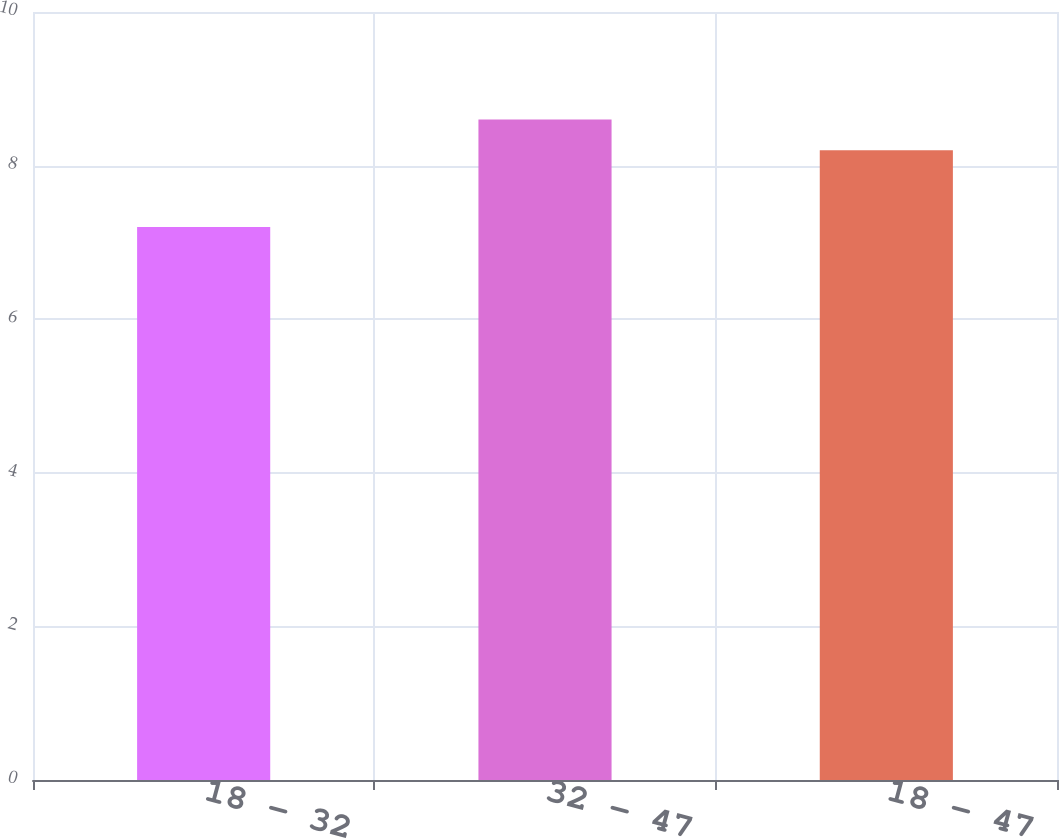<chart> <loc_0><loc_0><loc_500><loc_500><bar_chart><fcel>18 - 32<fcel>32 - 47<fcel>18 - 47<nl><fcel>7.2<fcel>8.6<fcel>8.2<nl></chart> 